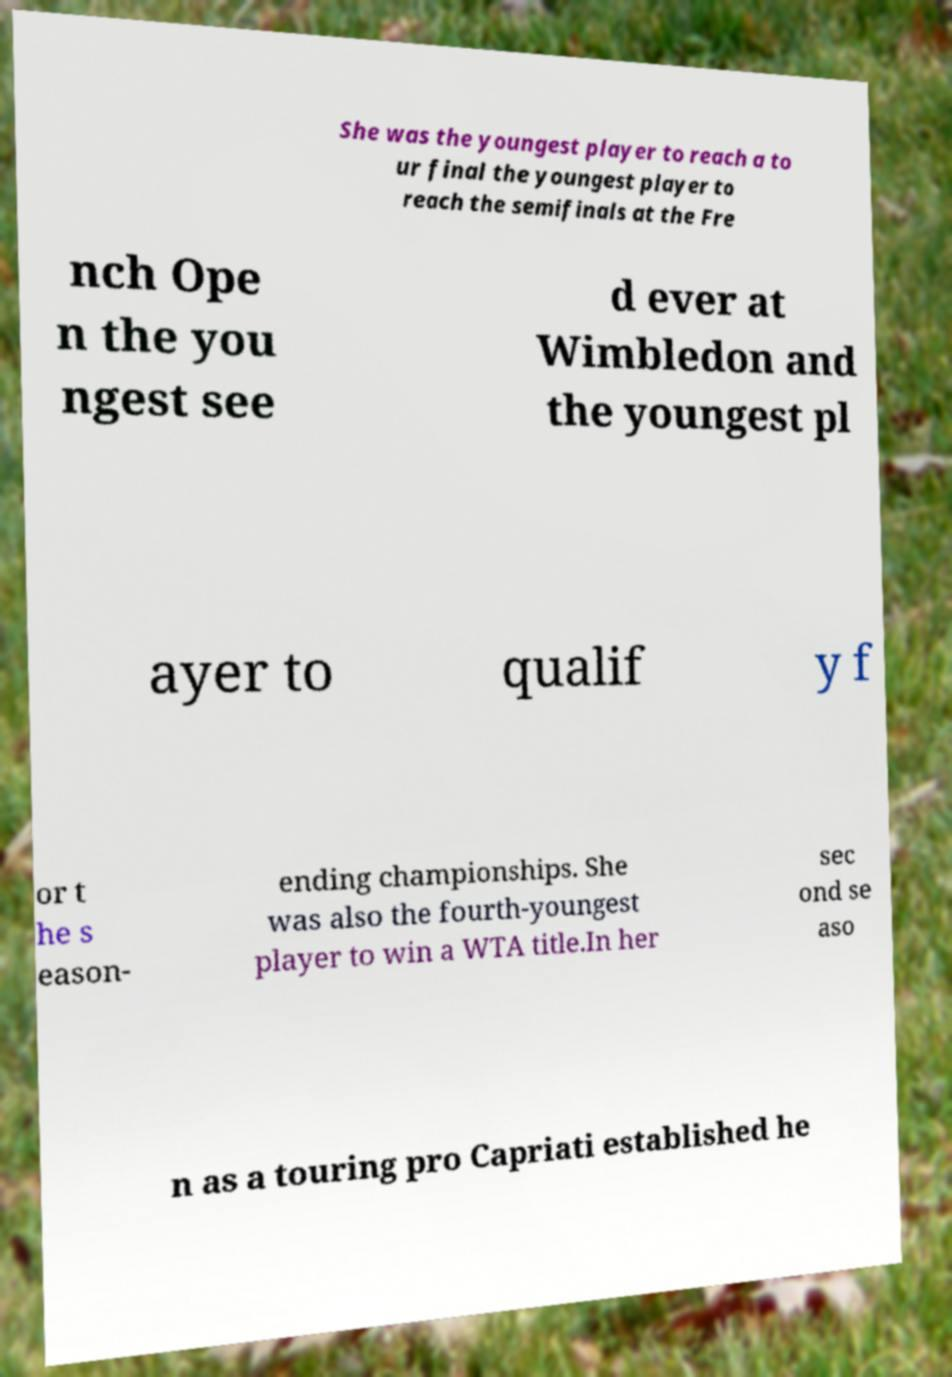Could you extract and type out the text from this image? She was the youngest player to reach a to ur final the youngest player to reach the semifinals at the Fre nch Ope n the you ngest see d ever at Wimbledon and the youngest pl ayer to qualif y f or t he s eason- ending championships. She was also the fourth-youngest player to win a WTA title.In her sec ond se aso n as a touring pro Capriati established he 